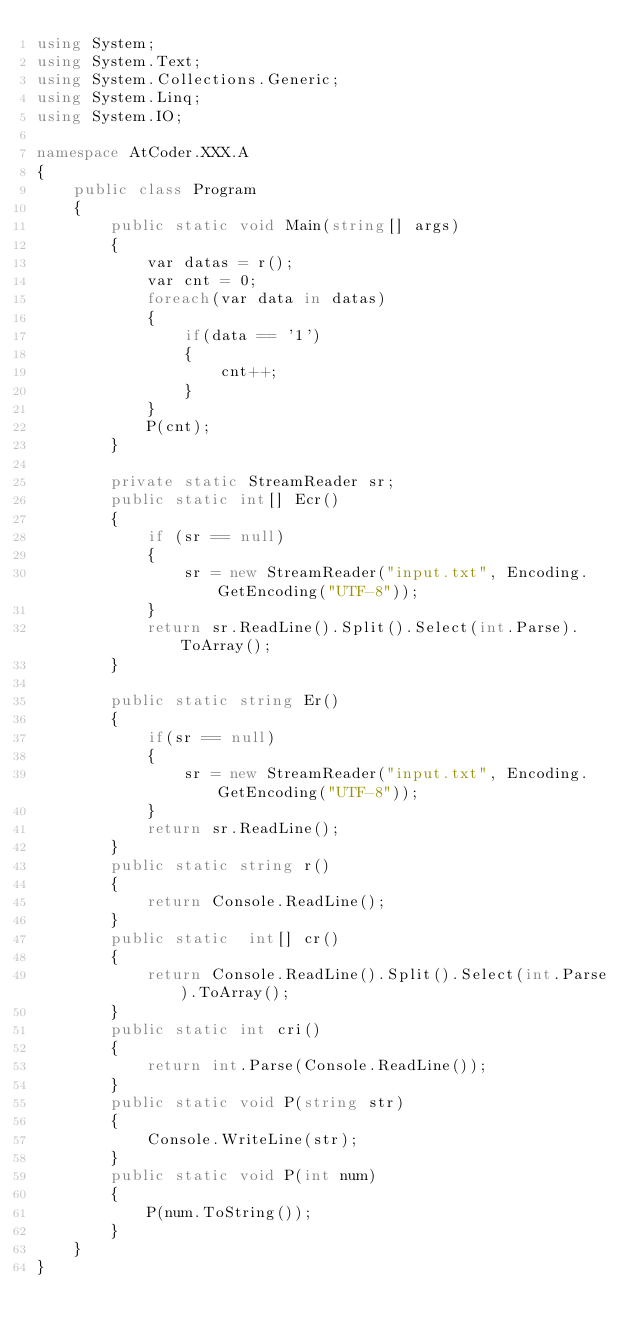Convert code to text. <code><loc_0><loc_0><loc_500><loc_500><_C#_>using System;
using System.Text;
using System.Collections.Generic;
using System.Linq;
using System.IO;

namespace AtCoder.XXX.A
{ 
    public class Program
    {
        public static void Main(string[] args)
        {
            var datas = r();
            var cnt = 0;
            foreach(var data in datas)
			{
                if(data == '1')
				{
                    cnt++;
				}
			}
            P(cnt);
        }

        private static StreamReader sr;
        public static int[] Ecr()
        {
            if (sr == null)
            {
                sr = new StreamReader("input.txt", Encoding.GetEncoding("UTF-8"));
            }
            return sr.ReadLine().Split().Select(int.Parse).ToArray();
        }

        public static string Er()
		{
            if(sr == null)
			{
                sr = new StreamReader("input.txt", Encoding.GetEncoding("UTF-8"));
            }
            return sr.ReadLine();
        }
        public static string r()
		{
            return Console.ReadLine();
		}
        public static  int[] cr()
        {
            return Console.ReadLine().Split().Select(int.Parse).ToArray();
        }
        public static int cri()
        {
            return int.Parse(Console.ReadLine());
        }
        public static void P(string str)
        {
            Console.WriteLine(str);
        }
        public static void P(int num)
        {
            P(num.ToString());
        }
    }
}
</code> 